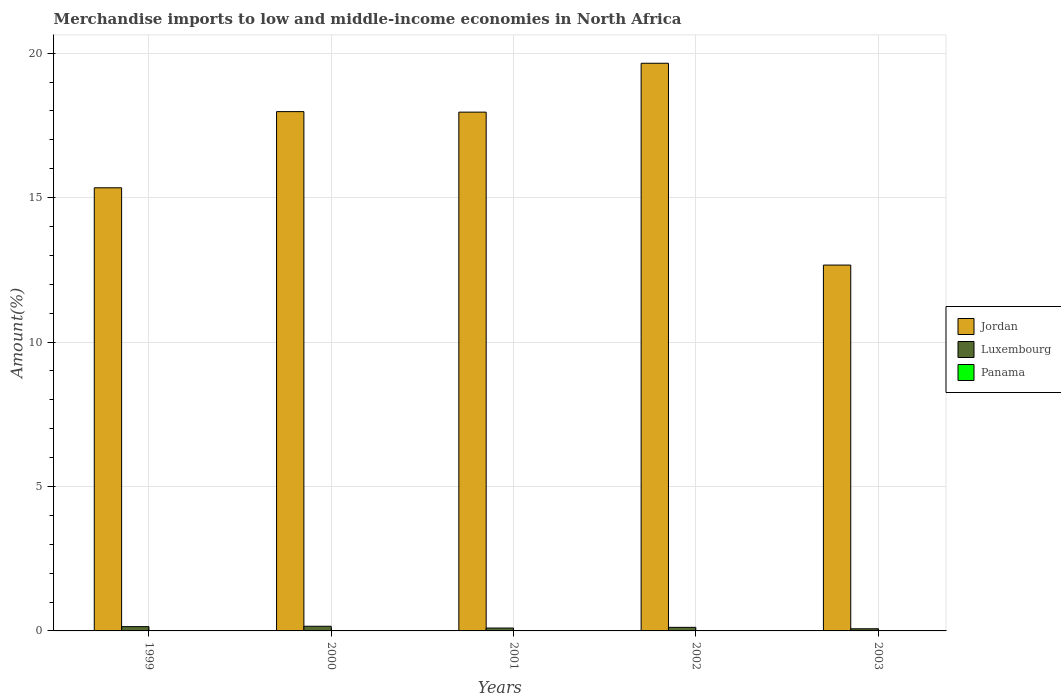How many different coloured bars are there?
Offer a very short reply. 3. How many groups of bars are there?
Provide a succinct answer. 5. How many bars are there on the 3rd tick from the left?
Ensure brevity in your answer.  3. What is the label of the 1st group of bars from the left?
Ensure brevity in your answer.  1999. What is the percentage of amount earned from merchandise imports in Panama in 1999?
Offer a terse response. 0. Across all years, what is the maximum percentage of amount earned from merchandise imports in Jordan?
Make the answer very short. 19.65. Across all years, what is the minimum percentage of amount earned from merchandise imports in Jordan?
Make the answer very short. 12.66. In which year was the percentage of amount earned from merchandise imports in Jordan maximum?
Give a very brief answer. 2002. In which year was the percentage of amount earned from merchandise imports in Jordan minimum?
Ensure brevity in your answer.  2003. What is the total percentage of amount earned from merchandise imports in Panama in the graph?
Provide a succinct answer. 0.02. What is the difference between the percentage of amount earned from merchandise imports in Luxembourg in 2001 and that in 2003?
Provide a succinct answer. 0.03. What is the difference between the percentage of amount earned from merchandise imports in Jordan in 2000 and the percentage of amount earned from merchandise imports in Panama in 2001?
Offer a terse response. 17.97. What is the average percentage of amount earned from merchandise imports in Jordan per year?
Provide a succinct answer. 16.72. In the year 2003, what is the difference between the percentage of amount earned from merchandise imports in Panama and percentage of amount earned from merchandise imports in Jordan?
Offer a very short reply. -12.66. In how many years, is the percentage of amount earned from merchandise imports in Panama greater than 13 %?
Make the answer very short. 0. What is the ratio of the percentage of amount earned from merchandise imports in Panama in 2000 to that in 2001?
Offer a terse response. 3.26. Is the percentage of amount earned from merchandise imports in Panama in 2001 less than that in 2003?
Keep it short and to the point. Yes. Is the difference between the percentage of amount earned from merchandise imports in Panama in 1999 and 2003 greater than the difference between the percentage of amount earned from merchandise imports in Jordan in 1999 and 2003?
Offer a very short reply. No. What is the difference between the highest and the second highest percentage of amount earned from merchandise imports in Panama?
Give a very brief answer. 0. What is the difference between the highest and the lowest percentage of amount earned from merchandise imports in Jordan?
Offer a very short reply. 6.99. In how many years, is the percentage of amount earned from merchandise imports in Luxembourg greater than the average percentage of amount earned from merchandise imports in Luxembourg taken over all years?
Your answer should be compact. 3. Is the sum of the percentage of amount earned from merchandise imports in Jordan in 1999 and 2002 greater than the maximum percentage of amount earned from merchandise imports in Luxembourg across all years?
Your response must be concise. Yes. What does the 1st bar from the left in 1999 represents?
Your answer should be compact. Jordan. What does the 1st bar from the right in 2000 represents?
Provide a short and direct response. Panama. How many bars are there?
Ensure brevity in your answer.  15. What is the difference between two consecutive major ticks on the Y-axis?
Make the answer very short. 5. Does the graph contain grids?
Offer a very short reply. Yes. Where does the legend appear in the graph?
Ensure brevity in your answer.  Center right. How many legend labels are there?
Keep it short and to the point. 3. What is the title of the graph?
Make the answer very short. Merchandise imports to low and middle-income economies in North Africa. Does "Ireland" appear as one of the legend labels in the graph?
Provide a short and direct response. No. What is the label or title of the X-axis?
Keep it short and to the point. Years. What is the label or title of the Y-axis?
Your answer should be very brief. Amount(%). What is the Amount(%) in Jordan in 1999?
Offer a terse response. 15.34. What is the Amount(%) of Luxembourg in 1999?
Provide a succinct answer. 0.15. What is the Amount(%) in Panama in 1999?
Make the answer very short. 0. What is the Amount(%) in Jordan in 2000?
Your response must be concise. 17.98. What is the Amount(%) in Luxembourg in 2000?
Offer a very short reply. 0.16. What is the Amount(%) in Panama in 2000?
Your response must be concise. 0. What is the Amount(%) of Jordan in 2001?
Provide a succinct answer. 17.96. What is the Amount(%) of Luxembourg in 2001?
Offer a terse response. 0.1. What is the Amount(%) in Panama in 2001?
Your answer should be very brief. 0. What is the Amount(%) in Jordan in 2002?
Your answer should be compact. 19.65. What is the Amount(%) of Luxembourg in 2002?
Your answer should be very brief. 0.12. What is the Amount(%) of Panama in 2002?
Offer a very short reply. 0. What is the Amount(%) in Jordan in 2003?
Ensure brevity in your answer.  12.66. What is the Amount(%) in Luxembourg in 2003?
Provide a succinct answer. 0.07. What is the Amount(%) in Panama in 2003?
Provide a short and direct response. 0. Across all years, what is the maximum Amount(%) of Jordan?
Offer a very short reply. 19.65. Across all years, what is the maximum Amount(%) in Luxembourg?
Offer a terse response. 0.16. Across all years, what is the maximum Amount(%) of Panama?
Your answer should be very brief. 0. Across all years, what is the minimum Amount(%) of Jordan?
Your answer should be very brief. 12.66. Across all years, what is the minimum Amount(%) in Luxembourg?
Make the answer very short. 0.07. Across all years, what is the minimum Amount(%) of Panama?
Give a very brief answer. 0. What is the total Amount(%) of Jordan in the graph?
Ensure brevity in your answer.  83.59. What is the total Amount(%) of Luxembourg in the graph?
Provide a succinct answer. 0.61. What is the total Amount(%) in Panama in the graph?
Your answer should be compact. 0.02. What is the difference between the Amount(%) of Jordan in 1999 and that in 2000?
Offer a very short reply. -2.64. What is the difference between the Amount(%) in Luxembourg in 1999 and that in 2000?
Provide a succinct answer. -0.01. What is the difference between the Amount(%) in Panama in 1999 and that in 2000?
Provide a succinct answer. -0. What is the difference between the Amount(%) of Jordan in 1999 and that in 2001?
Your answer should be compact. -2.62. What is the difference between the Amount(%) of Luxembourg in 1999 and that in 2001?
Provide a succinct answer. 0.05. What is the difference between the Amount(%) in Panama in 1999 and that in 2001?
Offer a very short reply. 0. What is the difference between the Amount(%) in Jordan in 1999 and that in 2002?
Offer a very short reply. -4.31. What is the difference between the Amount(%) of Luxembourg in 1999 and that in 2002?
Your response must be concise. 0.02. What is the difference between the Amount(%) in Panama in 1999 and that in 2002?
Make the answer very short. 0. What is the difference between the Amount(%) in Jordan in 1999 and that in 2003?
Provide a succinct answer. 2.67. What is the difference between the Amount(%) of Luxembourg in 1999 and that in 2003?
Offer a very short reply. 0.07. What is the difference between the Amount(%) in Panama in 1999 and that in 2003?
Give a very brief answer. -0. What is the difference between the Amount(%) in Jordan in 2000 and that in 2001?
Your response must be concise. 0.02. What is the difference between the Amount(%) in Luxembourg in 2000 and that in 2001?
Make the answer very short. 0.06. What is the difference between the Amount(%) of Panama in 2000 and that in 2001?
Give a very brief answer. 0. What is the difference between the Amount(%) in Jordan in 2000 and that in 2002?
Offer a very short reply. -1.67. What is the difference between the Amount(%) in Luxembourg in 2000 and that in 2002?
Provide a short and direct response. 0.04. What is the difference between the Amount(%) in Panama in 2000 and that in 2002?
Your response must be concise. 0. What is the difference between the Amount(%) in Jordan in 2000 and that in 2003?
Provide a short and direct response. 5.31. What is the difference between the Amount(%) in Luxembourg in 2000 and that in 2003?
Give a very brief answer. 0.09. What is the difference between the Amount(%) of Jordan in 2001 and that in 2002?
Give a very brief answer. -1.69. What is the difference between the Amount(%) of Luxembourg in 2001 and that in 2002?
Your answer should be compact. -0.02. What is the difference between the Amount(%) in Panama in 2001 and that in 2002?
Your answer should be very brief. -0. What is the difference between the Amount(%) in Jordan in 2001 and that in 2003?
Offer a terse response. 5.29. What is the difference between the Amount(%) in Luxembourg in 2001 and that in 2003?
Make the answer very short. 0.03. What is the difference between the Amount(%) in Panama in 2001 and that in 2003?
Provide a short and direct response. -0. What is the difference between the Amount(%) of Jordan in 2002 and that in 2003?
Ensure brevity in your answer.  6.99. What is the difference between the Amount(%) in Luxembourg in 2002 and that in 2003?
Your response must be concise. 0.05. What is the difference between the Amount(%) of Panama in 2002 and that in 2003?
Ensure brevity in your answer.  -0. What is the difference between the Amount(%) in Jordan in 1999 and the Amount(%) in Luxembourg in 2000?
Provide a short and direct response. 15.18. What is the difference between the Amount(%) in Jordan in 1999 and the Amount(%) in Panama in 2000?
Your response must be concise. 15.33. What is the difference between the Amount(%) in Luxembourg in 1999 and the Amount(%) in Panama in 2000?
Offer a terse response. 0.14. What is the difference between the Amount(%) in Jordan in 1999 and the Amount(%) in Luxembourg in 2001?
Your answer should be compact. 15.24. What is the difference between the Amount(%) of Jordan in 1999 and the Amount(%) of Panama in 2001?
Provide a short and direct response. 15.34. What is the difference between the Amount(%) of Luxembourg in 1999 and the Amount(%) of Panama in 2001?
Your answer should be very brief. 0.15. What is the difference between the Amount(%) of Jordan in 1999 and the Amount(%) of Luxembourg in 2002?
Keep it short and to the point. 15.22. What is the difference between the Amount(%) of Jordan in 1999 and the Amount(%) of Panama in 2002?
Your answer should be compact. 15.34. What is the difference between the Amount(%) of Luxembourg in 1999 and the Amount(%) of Panama in 2002?
Your response must be concise. 0.15. What is the difference between the Amount(%) of Jordan in 1999 and the Amount(%) of Luxembourg in 2003?
Keep it short and to the point. 15.26. What is the difference between the Amount(%) of Jordan in 1999 and the Amount(%) of Panama in 2003?
Provide a short and direct response. 15.33. What is the difference between the Amount(%) of Luxembourg in 1999 and the Amount(%) of Panama in 2003?
Your response must be concise. 0.14. What is the difference between the Amount(%) of Jordan in 2000 and the Amount(%) of Luxembourg in 2001?
Offer a terse response. 17.88. What is the difference between the Amount(%) in Jordan in 2000 and the Amount(%) in Panama in 2001?
Offer a terse response. 17.97. What is the difference between the Amount(%) in Luxembourg in 2000 and the Amount(%) in Panama in 2001?
Keep it short and to the point. 0.16. What is the difference between the Amount(%) of Jordan in 2000 and the Amount(%) of Luxembourg in 2002?
Provide a succinct answer. 17.85. What is the difference between the Amount(%) in Jordan in 2000 and the Amount(%) in Panama in 2002?
Offer a terse response. 17.97. What is the difference between the Amount(%) of Luxembourg in 2000 and the Amount(%) of Panama in 2002?
Make the answer very short. 0.16. What is the difference between the Amount(%) in Jordan in 2000 and the Amount(%) in Luxembourg in 2003?
Make the answer very short. 17.9. What is the difference between the Amount(%) of Jordan in 2000 and the Amount(%) of Panama in 2003?
Your answer should be very brief. 17.97. What is the difference between the Amount(%) of Luxembourg in 2000 and the Amount(%) of Panama in 2003?
Ensure brevity in your answer.  0.16. What is the difference between the Amount(%) in Jordan in 2001 and the Amount(%) in Luxembourg in 2002?
Provide a short and direct response. 17.83. What is the difference between the Amount(%) of Jordan in 2001 and the Amount(%) of Panama in 2002?
Your answer should be compact. 17.96. What is the difference between the Amount(%) in Luxembourg in 2001 and the Amount(%) in Panama in 2002?
Offer a very short reply. 0.1. What is the difference between the Amount(%) of Jordan in 2001 and the Amount(%) of Luxembourg in 2003?
Your response must be concise. 17.88. What is the difference between the Amount(%) in Jordan in 2001 and the Amount(%) in Panama in 2003?
Give a very brief answer. 17.95. What is the difference between the Amount(%) of Luxembourg in 2001 and the Amount(%) of Panama in 2003?
Keep it short and to the point. 0.1. What is the difference between the Amount(%) in Jordan in 2002 and the Amount(%) in Luxembourg in 2003?
Provide a succinct answer. 19.58. What is the difference between the Amount(%) in Jordan in 2002 and the Amount(%) in Panama in 2003?
Your response must be concise. 19.65. What is the difference between the Amount(%) in Luxembourg in 2002 and the Amount(%) in Panama in 2003?
Your answer should be very brief. 0.12. What is the average Amount(%) in Jordan per year?
Provide a succinct answer. 16.72. What is the average Amount(%) in Luxembourg per year?
Offer a terse response. 0.12. What is the average Amount(%) in Panama per year?
Offer a terse response. 0. In the year 1999, what is the difference between the Amount(%) of Jordan and Amount(%) of Luxembourg?
Your response must be concise. 15.19. In the year 1999, what is the difference between the Amount(%) of Jordan and Amount(%) of Panama?
Offer a terse response. 15.33. In the year 1999, what is the difference between the Amount(%) of Luxembourg and Amount(%) of Panama?
Provide a short and direct response. 0.14. In the year 2000, what is the difference between the Amount(%) of Jordan and Amount(%) of Luxembourg?
Make the answer very short. 17.81. In the year 2000, what is the difference between the Amount(%) of Jordan and Amount(%) of Panama?
Give a very brief answer. 17.97. In the year 2000, what is the difference between the Amount(%) in Luxembourg and Amount(%) in Panama?
Offer a terse response. 0.16. In the year 2001, what is the difference between the Amount(%) in Jordan and Amount(%) in Luxembourg?
Keep it short and to the point. 17.86. In the year 2001, what is the difference between the Amount(%) of Jordan and Amount(%) of Panama?
Ensure brevity in your answer.  17.96. In the year 2001, what is the difference between the Amount(%) of Luxembourg and Amount(%) of Panama?
Offer a terse response. 0.1. In the year 2002, what is the difference between the Amount(%) of Jordan and Amount(%) of Luxembourg?
Give a very brief answer. 19.53. In the year 2002, what is the difference between the Amount(%) of Jordan and Amount(%) of Panama?
Your response must be concise. 19.65. In the year 2002, what is the difference between the Amount(%) of Luxembourg and Amount(%) of Panama?
Offer a very short reply. 0.12. In the year 2003, what is the difference between the Amount(%) in Jordan and Amount(%) in Luxembourg?
Your response must be concise. 12.59. In the year 2003, what is the difference between the Amount(%) in Jordan and Amount(%) in Panama?
Ensure brevity in your answer.  12.66. In the year 2003, what is the difference between the Amount(%) in Luxembourg and Amount(%) in Panama?
Your response must be concise. 0.07. What is the ratio of the Amount(%) of Jordan in 1999 to that in 2000?
Offer a terse response. 0.85. What is the ratio of the Amount(%) of Luxembourg in 1999 to that in 2000?
Provide a succinct answer. 0.92. What is the ratio of the Amount(%) of Panama in 1999 to that in 2000?
Provide a short and direct response. 0.92. What is the ratio of the Amount(%) of Jordan in 1999 to that in 2001?
Keep it short and to the point. 0.85. What is the ratio of the Amount(%) in Luxembourg in 1999 to that in 2001?
Make the answer very short. 1.49. What is the ratio of the Amount(%) in Panama in 1999 to that in 2001?
Your answer should be compact. 3.01. What is the ratio of the Amount(%) of Jordan in 1999 to that in 2002?
Offer a very short reply. 0.78. What is the ratio of the Amount(%) in Luxembourg in 1999 to that in 2002?
Give a very brief answer. 1.2. What is the ratio of the Amount(%) in Panama in 1999 to that in 2002?
Keep it short and to the point. 2. What is the ratio of the Amount(%) of Jordan in 1999 to that in 2003?
Ensure brevity in your answer.  1.21. What is the ratio of the Amount(%) in Luxembourg in 1999 to that in 2003?
Make the answer very short. 1.99. What is the ratio of the Amount(%) in Panama in 1999 to that in 2003?
Provide a short and direct response. 0.95. What is the ratio of the Amount(%) of Jordan in 2000 to that in 2001?
Your answer should be very brief. 1. What is the ratio of the Amount(%) in Luxembourg in 2000 to that in 2001?
Give a very brief answer. 1.62. What is the ratio of the Amount(%) in Panama in 2000 to that in 2001?
Ensure brevity in your answer.  3.26. What is the ratio of the Amount(%) in Jordan in 2000 to that in 2002?
Provide a succinct answer. 0.91. What is the ratio of the Amount(%) in Luxembourg in 2000 to that in 2002?
Offer a terse response. 1.31. What is the ratio of the Amount(%) of Panama in 2000 to that in 2002?
Make the answer very short. 2.16. What is the ratio of the Amount(%) of Jordan in 2000 to that in 2003?
Offer a very short reply. 1.42. What is the ratio of the Amount(%) in Luxembourg in 2000 to that in 2003?
Keep it short and to the point. 2.17. What is the ratio of the Amount(%) in Jordan in 2001 to that in 2002?
Make the answer very short. 0.91. What is the ratio of the Amount(%) of Luxembourg in 2001 to that in 2002?
Give a very brief answer. 0.81. What is the ratio of the Amount(%) of Panama in 2001 to that in 2002?
Give a very brief answer. 0.66. What is the ratio of the Amount(%) in Jordan in 2001 to that in 2003?
Your answer should be compact. 1.42. What is the ratio of the Amount(%) in Luxembourg in 2001 to that in 2003?
Give a very brief answer. 1.34. What is the ratio of the Amount(%) of Panama in 2001 to that in 2003?
Your answer should be compact. 0.31. What is the ratio of the Amount(%) in Jordan in 2002 to that in 2003?
Ensure brevity in your answer.  1.55. What is the ratio of the Amount(%) of Luxembourg in 2002 to that in 2003?
Offer a terse response. 1.66. What is the ratio of the Amount(%) in Panama in 2002 to that in 2003?
Your response must be concise. 0.47. What is the difference between the highest and the second highest Amount(%) in Jordan?
Offer a terse response. 1.67. What is the difference between the highest and the second highest Amount(%) in Luxembourg?
Provide a short and direct response. 0.01. What is the difference between the highest and the lowest Amount(%) in Jordan?
Offer a terse response. 6.99. What is the difference between the highest and the lowest Amount(%) in Luxembourg?
Provide a short and direct response. 0.09. What is the difference between the highest and the lowest Amount(%) of Panama?
Offer a very short reply. 0. 